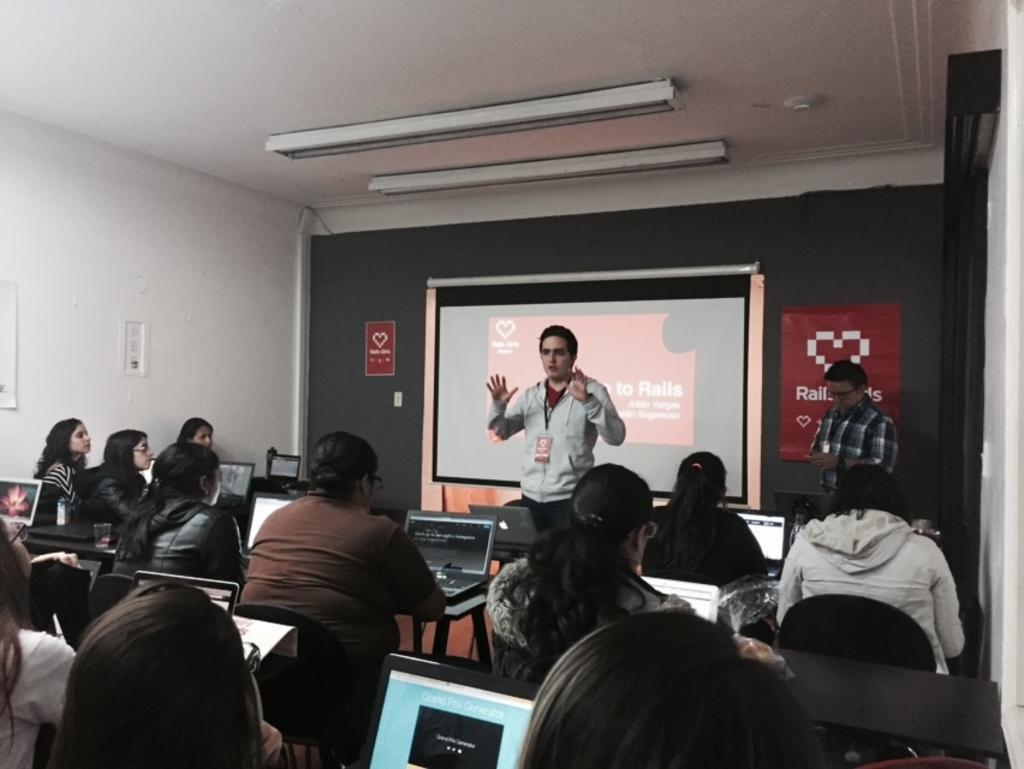How would you summarize this image in a sentence or two? Here in this picture we can see a group of people sitting on chairs with tables in front of them having laptops on it and in the middle we can see a person speaking to them and behind him we can see a projector screen present and we can also see a person standing beside him and on the wall we can see posters present and on the roof we can see lights present over there. 